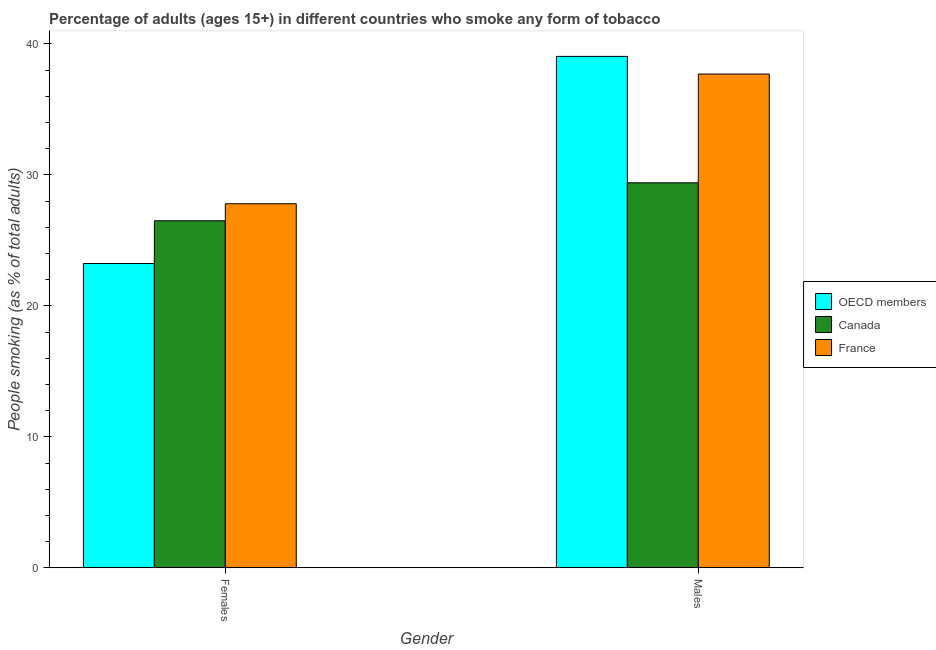How many different coloured bars are there?
Offer a terse response. 3. How many groups of bars are there?
Offer a terse response. 2. Are the number of bars per tick equal to the number of legend labels?
Ensure brevity in your answer.  Yes. Are the number of bars on each tick of the X-axis equal?
Your answer should be compact. Yes. How many bars are there on the 2nd tick from the left?
Give a very brief answer. 3. What is the label of the 1st group of bars from the left?
Offer a very short reply. Females. What is the percentage of males who smoke in Canada?
Your answer should be compact. 29.4. Across all countries, what is the maximum percentage of males who smoke?
Your answer should be very brief. 39.05. Across all countries, what is the minimum percentage of females who smoke?
Make the answer very short. 23.24. In which country was the percentage of females who smoke maximum?
Offer a terse response. France. In which country was the percentage of females who smoke minimum?
Make the answer very short. OECD members. What is the total percentage of males who smoke in the graph?
Provide a succinct answer. 106.15. What is the difference between the percentage of females who smoke in OECD members and that in France?
Provide a short and direct response. -4.56. What is the difference between the percentage of males who smoke in OECD members and the percentage of females who smoke in France?
Your answer should be very brief. 11.25. What is the average percentage of females who smoke per country?
Give a very brief answer. 25.85. What is the difference between the percentage of males who smoke and percentage of females who smoke in Canada?
Your response must be concise. 2.9. What is the ratio of the percentage of females who smoke in OECD members to that in Canada?
Give a very brief answer. 0.88. In how many countries, is the percentage of males who smoke greater than the average percentage of males who smoke taken over all countries?
Provide a succinct answer. 2. What does the 1st bar from the left in Males represents?
Provide a short and direct response. OECD members. What does the 3rd bar from the right in Males represents?
Your answer should be compact. OECD members. How many bars are there?
Provide a short and direct response. 6. Are all the bars in the graph horizontal?
Your answer should be compact. No. How many countries are there in the graph?
Provide a succinct answer. 3. What is the difference between two consecutive major ticks on the Y-axis?
Provide a succinct answer. 10. Are the values on the major ticks of Y-axis written in scientific E-notation?
Keep it short and to the point. No. Does the graph contain any zero values?
Provide a succinct answer. No. Does the graph contain grids?
Give a very brief answer. No. How are the legend labels stacked?
Your answer should be very brief. Vertical. What is the title of the graph?
Make the answer very short. Percentage of adults (ages 15+) in different countries who smoke any form of tobacco. What is the label or title of the X-axis?
Give a very brief answer. Gender. What is the label or title of the Y-axis?
Offer a very short reply. People smoking (as % of total adults). What is the People smoking (as % of total adults) of OECD members in Females?
Offer a very short reply. 23.24. What is the People smoking (as % of total adults) of Canada in Females?
Your response must be concise. 26.5. What is the People smoking (as % of total adults) in France in Females?
Your response must be concise. 27.8. What is the People smoking (as % of total adults) of OECD members in Males?
Offer a terse response. 39.05. What is the People smoking (as % of total adults) of Canada in Males?
Offer a very short reply. 29.4. What is the People smoking (as % of total adults) in France in Males?
Ensure brevity in your answer.  37.7. Across all Gender, what is the maximum People smoking (as % of total adults) in OECD members?
Provide a short and direct response. 39.05. Across all Gender, what is the maximum People smoking (as % of total adults) of Canada?
Give a very brief answer. 29.4. Across all Gender, what is the maximum People smoking (as % of total adults) of France?
Offer a very short reply. 37.7. Across all Gender, what is the minimum People smoking (as % of total adults) of OECD members?
Give a very brief answer. 23.24. Across all Gender, what is the minimum People smoking (as % of total adults) of France?
Give a very brief answer. 27.8. What is the total People smoking (as % of total adults) in OECD members in the graph?
Ensure brevity in your answer.  62.28. What is the total People smoking (as % of total adults) in Canada in the graph?
Ensure brevity in your answer.  55.9. What is the total People smoking (as % of total adults) in France in the graph?
Make the answer very short. 65.5. What is the difference between the People smoking (as % of total adults) in OECD members in Females and that in Males?
Give a very brief answer. -15.81. What is the difference between the People smoking (as % of total adults) in OECD members in Females and the People smoking (as % of total adults) in Canada in Males?
Offer a very short reply. -6.16. What is the difference between the People smoking (as % of total adults) in OECD members in Females and the People smoking (as % of total adults) in France in Males?
Your answer should be very brief. -14.46. What is the average People smoking (as % of total adults) in OECD members per Gender?
Make the answer very short. 31.14. What is the average People smoking (as % of total adults) in Canada per Gender?
Offer a terse response. 27.95. What is the average People smoking (as % of total adults) in France per Gender?
Make the answer very short. 32.75. What is the difference between the People smoking (as % of total adults) of OECD members and People smoking (as % of total adults) of Canada in Females?
Your answer should be compact. -3.26. What is the difference between the People smoking (as % of total adults) of OECD members and People smoking (as % of total adults) of France in Females?
Your answer should be compact. -4.56. What is the difference between the People smoking (as % of total adults) of OECD members and People smoking (as % of total adults) of Canada in Males?
Offer a terse response. 9.65. What is the difference between the People smoking (as % of total adults) in OECD members and People smoking (as % of total adults) in France in Males?
Keep it short and to the point. 1.35. What is the ratio of the People smoking (as % of total adults) in OECD members in Females to that in Males?
Your answer should be very brief. 0.6. What is the ratio of the People smoking (as % of total adults) in Canada in Females to that in Males?
Provide a short and direct response. 0.9. What is the ratio of the People smoking (as % of total adults) of France in Females to that in Males?
Make the answer very short. 0.74. What is the difference between the highest and the second highest People smoking (as % of total adults) in OECD members?
Make the answer very short. 15.81. What is the difference between the highest and the second highest People smoking (as % of total adults) in Canada?
Provide a succinct answer. 2.9. What is the difference between the highest and the second highest People smoking (as % of total adults) in France?
Provide a succinct answer. 9.9. What is the difference between the highest and the lowest People smoking (as % of total adults) of OECD members?
Make the answer very short. 15.81. What is the difference between the highest and the lowest People smoking (as % of total adults) in France?
Your response must be concise. 9.9. 